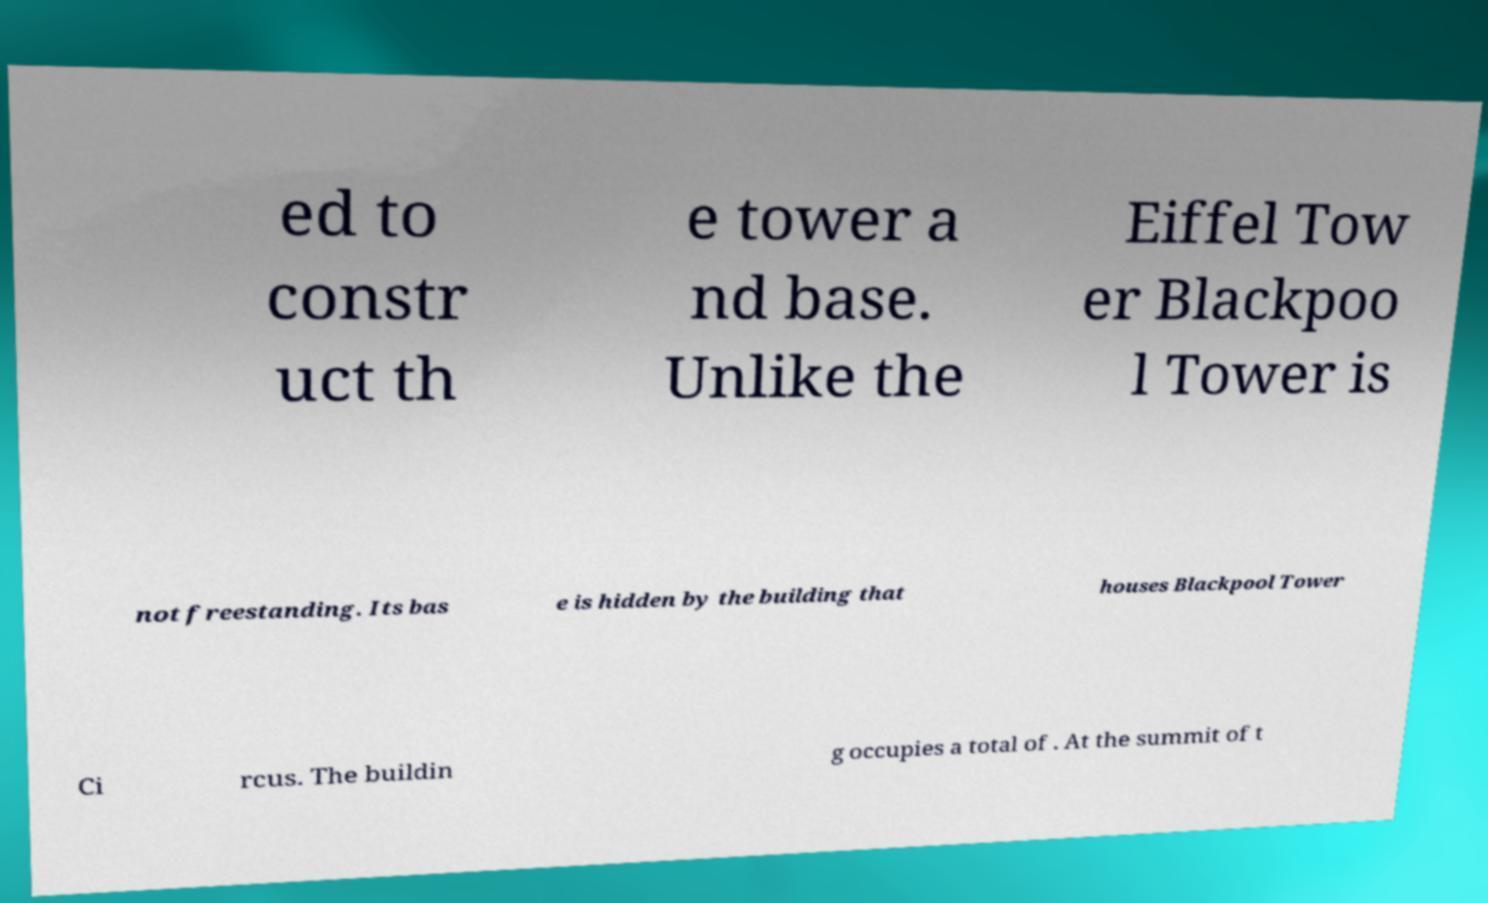Could you extract and type out the text from this image? ed to constr uct th e tower a nd base. Unlike the Eiffel Tow er Blackpoo l Tower is not freestanding. Its bas e is hidden by the building that houses Blackpool Tower Ci rcus. The buildin g occupies a total of . At the summit of t 